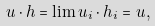Convert formula to latex. <formula><loc_0><loc_0><loc_500><loc_500>u \cdot h = \lim u _ { i } \cdot h _ { i } = u ,</formula> 